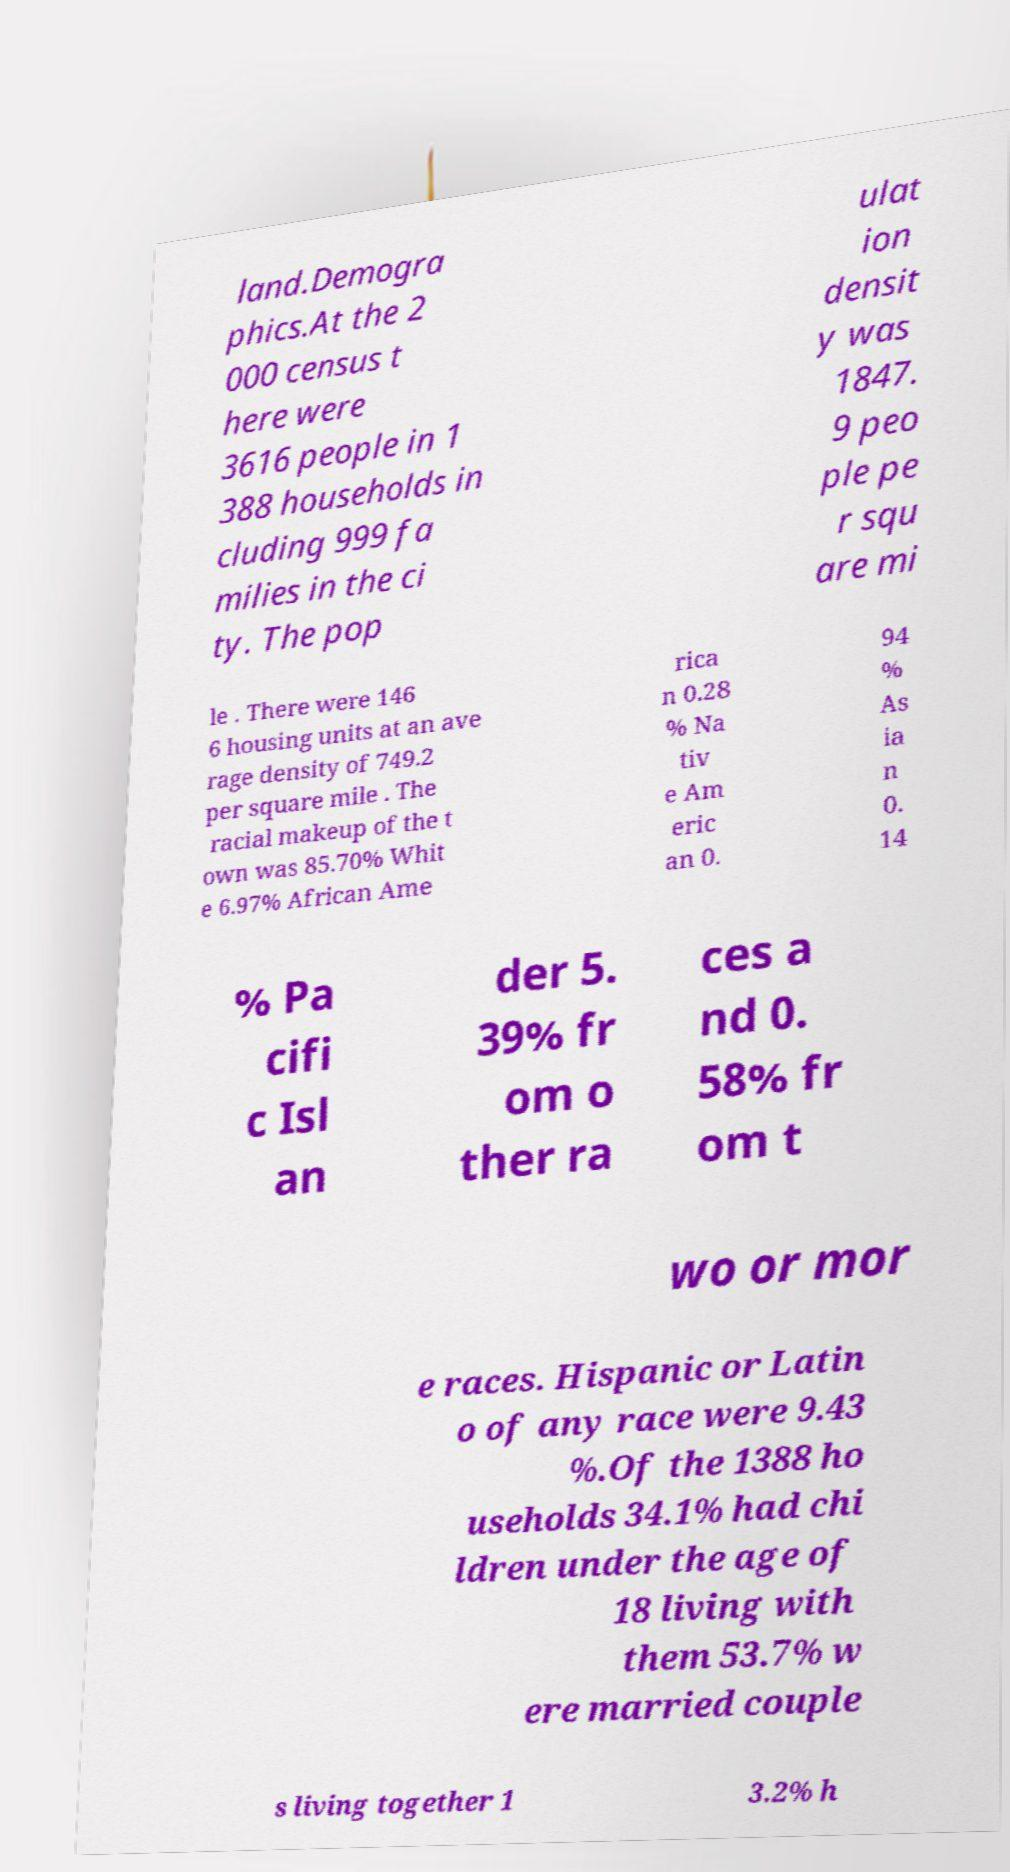For documentation purposes, I need the text within this image transcribed. Could you provide that? land.Demogra phics.At the 2 000 census t here were 3616 people in 1 388 households in cluding 999 fa milies in the ci ty. The pop ulat ion densit y was 1847. 9 peo ple pe r squ are mi le . There were 146 6 housing units at an ave rage density of 749.2 per square mile . The racial makeup of the t own was 85.70% Whit e 6.97% African Ame rica n 0.28 % Na tiv e Am eric an 0. 94 % As ia n 0. 14 % Pa cifi c Isl an der 5. 39% fr om o ther ra ces a nd 0. 58% fr om t wo or mor e races. Hispanic or Latin o of any race were 9.43 %.Of the 1388 ho useholds 34.1% had chi ldren under the age of 18 living with them 53.7% w ere married couple s living together 1 3.2% h 